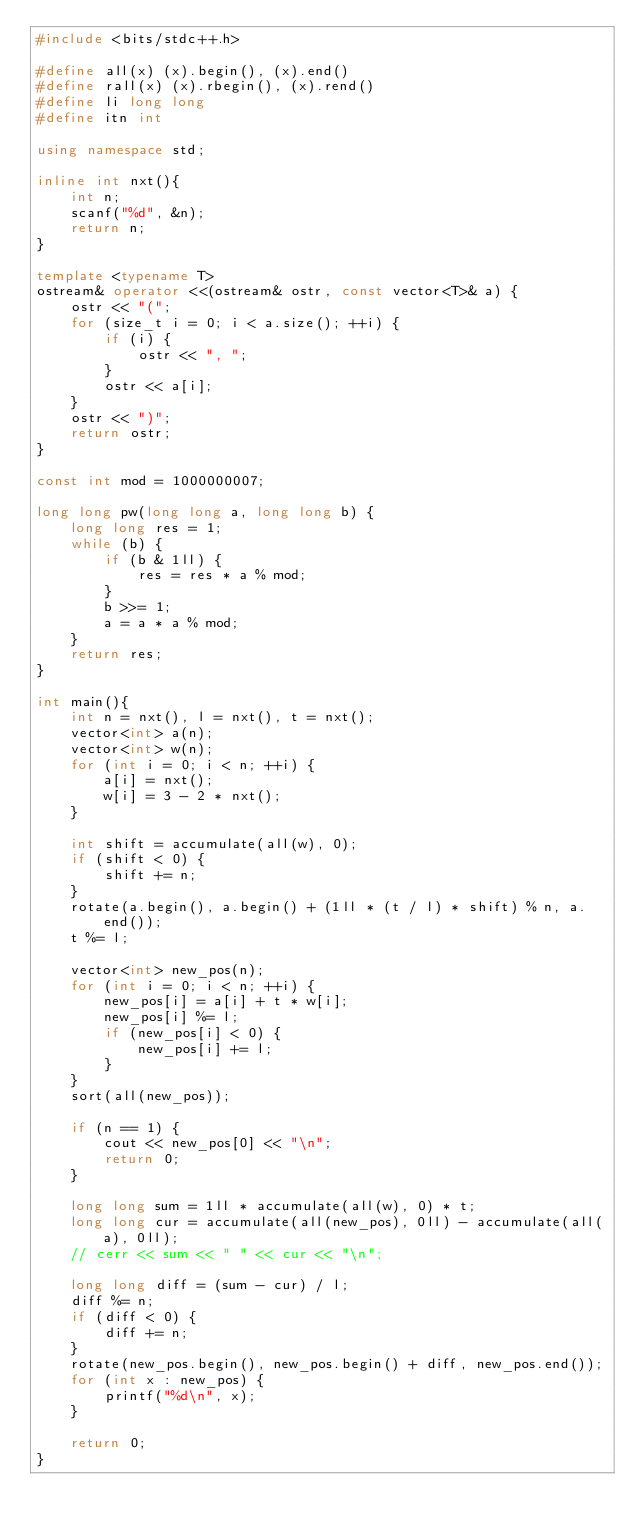<code> <loc_0><loc_0><loc_500><loc_500><_C++_>#include <bits/stdc++.h>
 
#define all(x) (x).begin(), (x).end()
#define rall(x) (x).rbegin(), (x).rend()
#define li long long
#define itn int
 
using namespace std;
 
inline int nxt(){
	int n;
	scanf("%d", &n);
	return n;
}

template <typename T>
ostream& operator <<(ostream& ostr, const vector<T>& a) {
	ostr << "(";
	for (size_t i = 0; i < a.size(); ++i) {
		if (i) {
			ostr << ", ";
		}
		ostr << a[i];
	}
	ostr << ")";
	return ostr;
}

const int mod = 1000000007;

long long pw(long long a, long long b) {
	long long res = 1;
	while (b) {
		if (b & 1ll) {
			res = res * a % mod;
		}
		b >>= 1;
		a = a * a % mod;
	}
	return res;
}

int main(){
	int n = nxt(), l = nxt(), t = nxt();
	vector<int> a(n);
	vector<int> w(n);
	for (int i = 0; i < n; ++i) {
		a[i] = nxt();
		w[i] = 3 - 2 * nxt();
	}

	int shift = accumulate(all(w), 0);
	if (shift < 0) {
		shift += n;
	}
	rotate(a.begin(), a.begin() + (1ll * (t / l) * shift) % n, a.end());
	t %= l;

	vector<int> new_pos(n);
	for (int i = 0; i < n; ++i) {
		new_pos[i] = a[i] + t * w[i];
		new_pos[i] %= l;
		if (new_pos[i] < 0) {
			new_pos[i] += l;
		}
	}
	sort(all(new_pos));

	if (n == 1) {
		cout << new_pos[0] << "\n";
		return 0;
	}

	long long sum = 1ll * accumulate(all(w), 0) * t;
	long long cur = accumulate(all(new_pos), 0ll) - accumulate(all(a), 0ll);
	// cerr << sum << " " << cur << "\n";

	long long diff = (sum - cur) / l;
	diff %= n;
	if (diff < 0) {
		diff += n;
	}
	rotate(new_pos.begin(), new_pos.begin() + diff, new_pos.end());
	for (int x : new_pos) {
		printf("%d\n", x);
	}

	return 0;
}</code> 